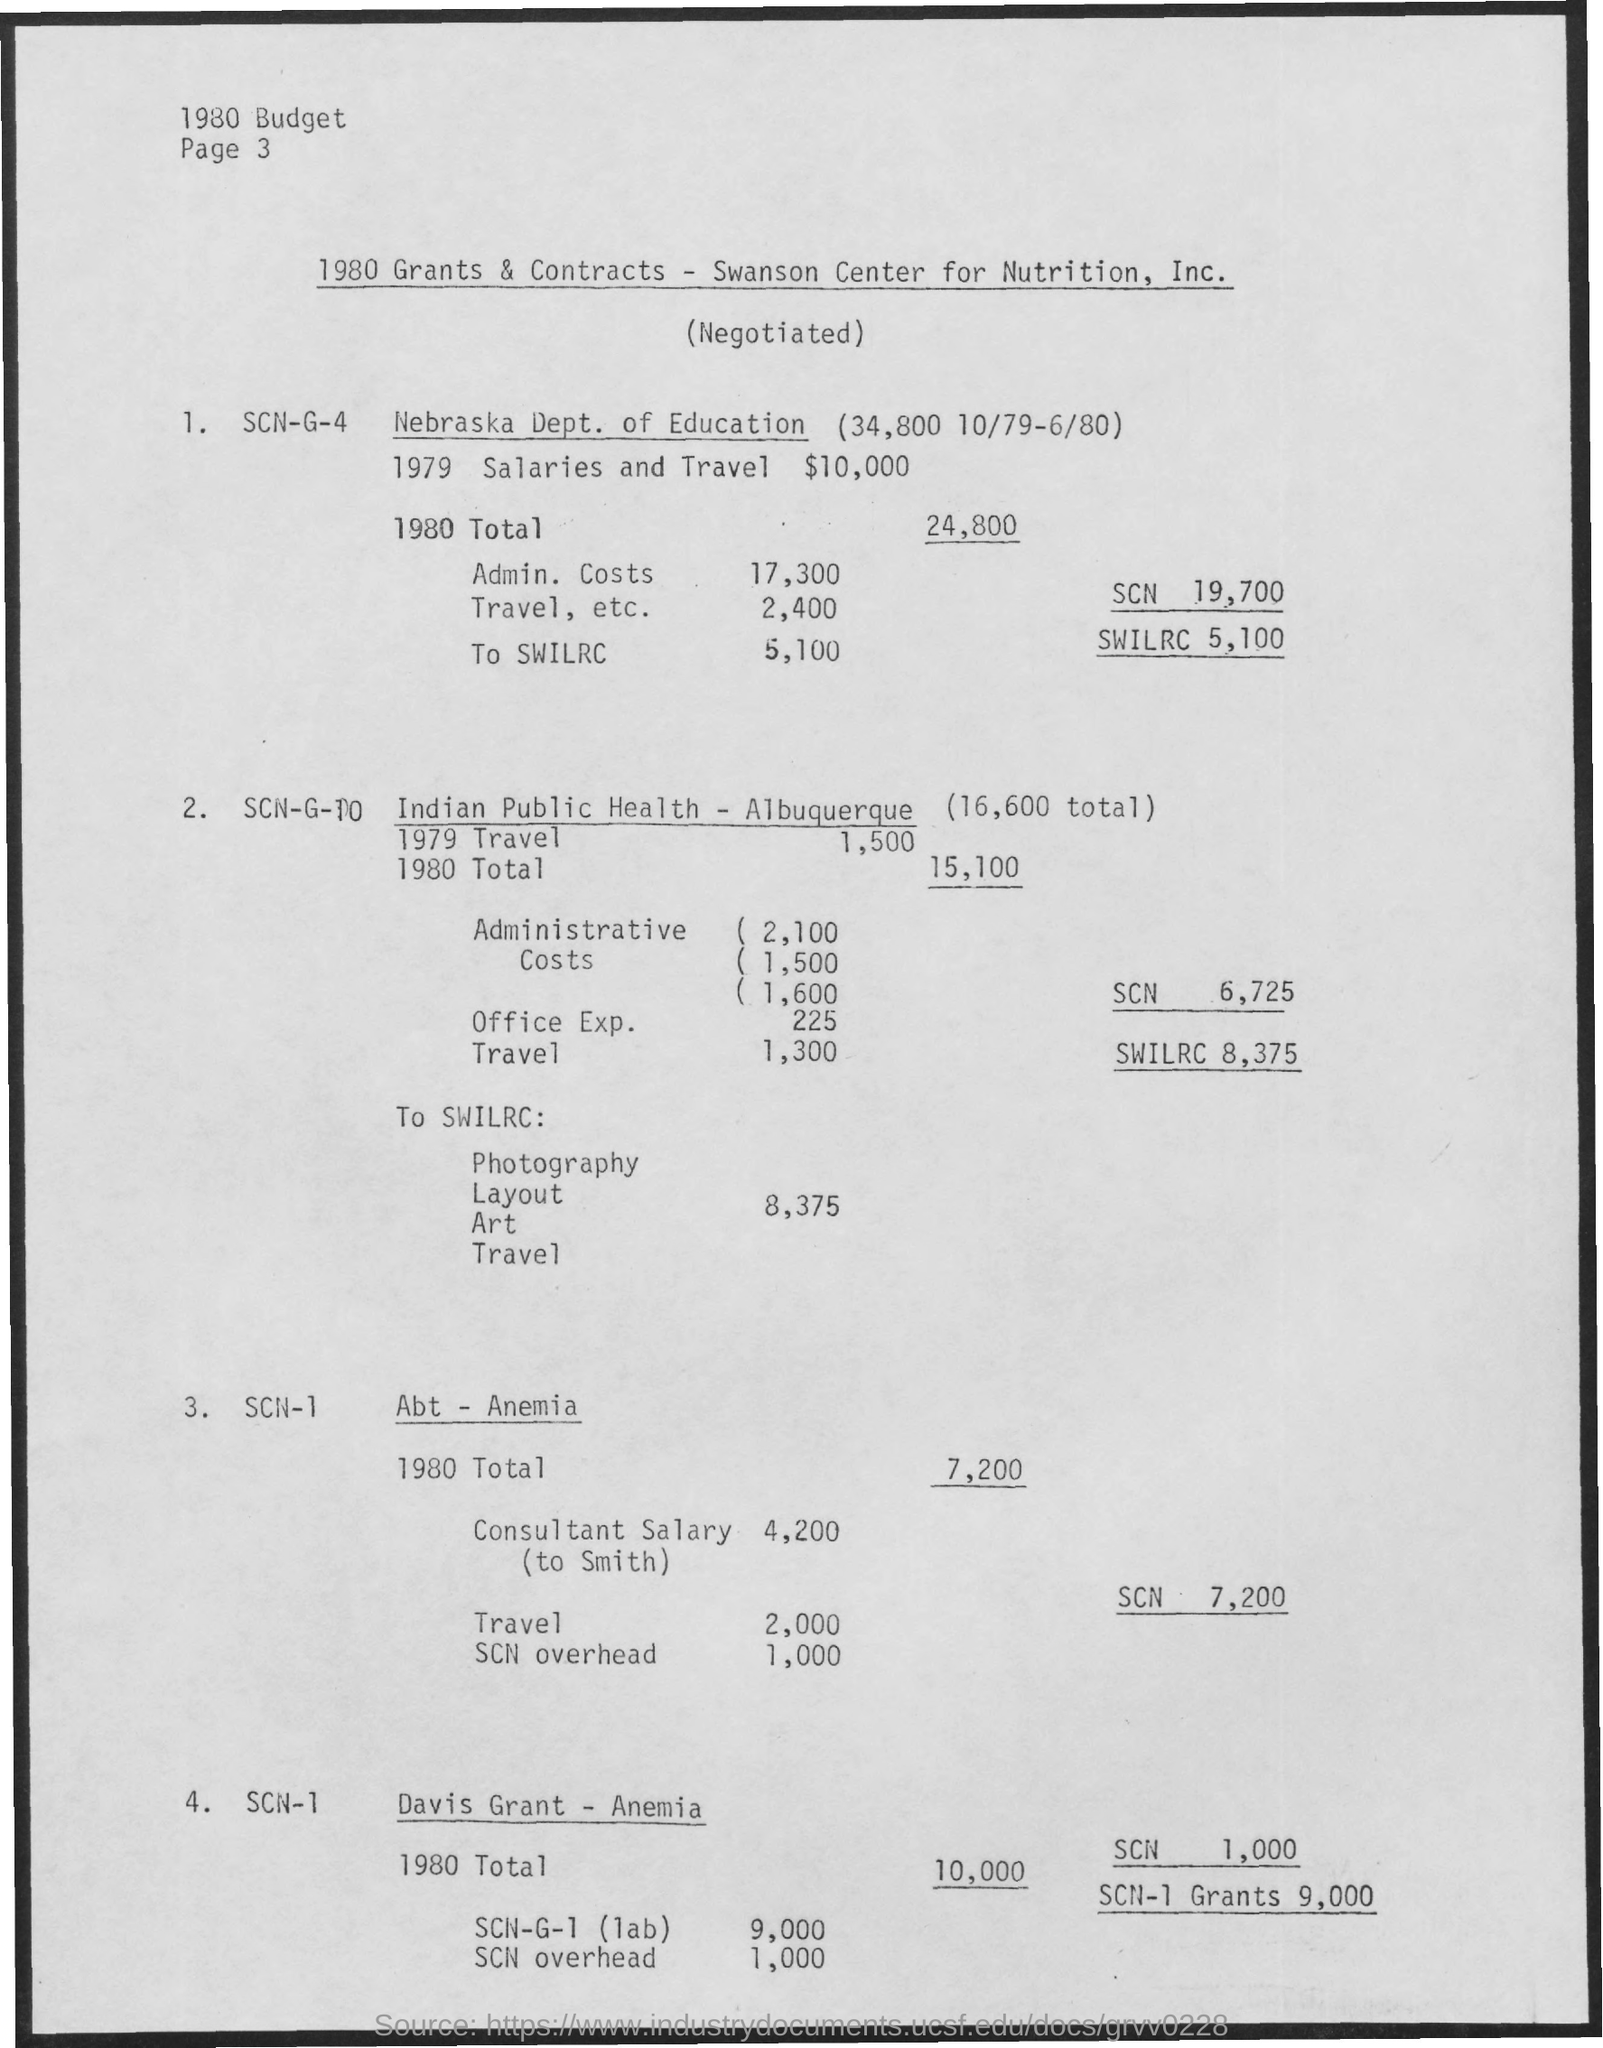What is the 1979 salaries and travel for Nebraska Dept. of Education? In 1979, the Nebraska Department of Education was allocated $10,000 for salaries and travel, as per the 1980 Grants & Contracts document for the Swanson Center for Nutrition, Inc. 